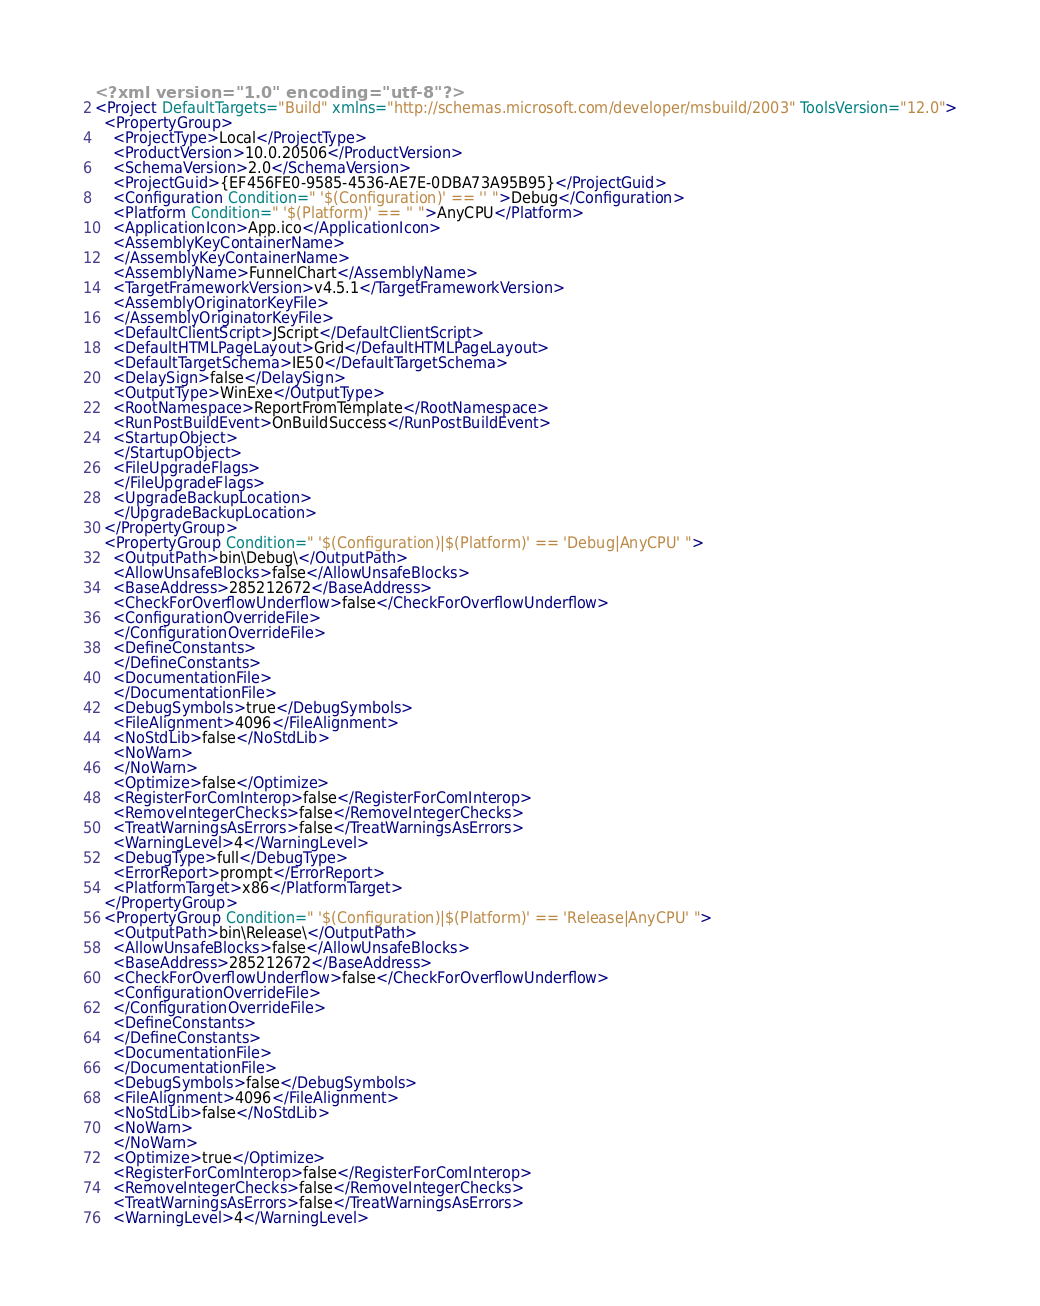Convert code to text. <code><loc_0><loc_0><loc_500><loc_500><_XML_><?xml version="1.0" encoding="utf-8"?>
<Project DefaultTargets="Build" xmlns="http://schemas.microsoft.com/developer/msbuild/2003" ToolsVersion="12.0">
  <PropertyGroup>
    <ProjectType>Local</ProjectType>
    <ProductVersion>10.0.20506</ProductVersion>
    <SchemaVersion>2.0</SchemaVersion>
    <ProjectGuid>{EF456FE0-9585-4536-AE7E-0DBA73A95B95}</ProjectGuid>
    <Configuration Condition=" '$(Configuration)' == '' ">Debug</Configuration>
    <Platform Condition=" '$(Platform)' == '' ">AnyCPU</Platform>
    <ApplicationIcon>App.ico</ApplicationIcon>
    <AssemblyKeyContainerName>
    </AssemblyKeyContainerName>
    <AssemblyName>FunnelChart</AssemblyName>
    <TargetFrameworkVersion>v4.5.1</TargetFrameworkVersion>
    <AssemblyOriginatorKeyFile>
    </AssemblyOriginatorKeyFile>
    <DefaultClientScript>JScript</DefaultClientScript>
    <DefaultHTMLPageLayout>Grid</DefaultHTMLPageLayout>
    <DefaultTargetSchema>IE50</DefaultTargetSchema>
    <DelaySign>false</DelaySign>
    <OutputType>WinExe</OutputType>
    <RootNamespace>ReportFromTemplate</RootNamespace>
    <RunPostBuildEvent>OnBuildSuccess</RunPostBuildEvent>
    <StartupObject>
    </StartupObject>
    <FileUpgradeFlags>
    </FileUpgradeFlags>
    <UpgradeBackupLocation>
    </UpgradeBackupLocation>
  </PropertyGroup>
  <PropertyGroup Condition=" '$(Configuration)|$(Platform)' == 'Debug|AnyCPU' ">
    <OutputPath>bin\Debug\</OutputPath>
    <AllowUnsafeBlocks>false</AllowUnsafeBlocks>
    <BaseAddress>285212672</BaseAddress>
    <CheckForOverflowUnderflow>false</CheckForOverflowUnderflow>
    <ConfigurationOverrideFile>
    </ConfigurationOverrideFile>
    <DefineConstants>
    </DefineConstants>
    <DocumentationFile>
    </DocumentationFile>
    <DebugSymbols>true</DebugSymbols>
    <FileAlignment>4096</FileAlignment>
    <NoStdLib>false</NoStdLib>
    <NoWarn>
    </NoWarn>
    <Optimize>false</Optimize>
    <RegisterForComInterop>false</RegisterForComInterop>
    <RemoveIntegerChecks>false</RemoveIntegerChecks>
    <TreatWarningsAsErrors>false</TreatWarningsAsErrors>
    <WarningLevel>4</WarningLevel>
    <DebugType>full</DebugType>
    <ErrorReport>prompt</ErrorReport>
    <PlatformTarget>x86</PlatformTarget>
  </PropertyGroup>
  <PropertyGroup Condition=" '$(Configuration)|$(Platform)' == 'Release|AnyCPU' ">
    <OutputPath>bin\Release\</OutputPath>
    <AllowUnsafeBlocks>false</AllowUnsafeBlocks>
    <BaseAddress>285212672</BaseAddress>
    <CheckForOverflowUnderflow>false</CheckForOverflowUnderflow>
    <ConfigurationOverrideFile>
    </ConfigurationOverrideFile>
    <DefineConstants>
    </DefineConstants>
    <DocumentationFile>
    </DocumentationFile>
    <DebugSymbols>false</DebugSymbols>
    <FileAlignment>4096</FileAlignment>
    <NoStdLib>false</NoStdLib>
    <NoWarn>
    </NoWarn>
    <Optimize>true</Optimize>
    <RegisterForComInterop>false</RegisterForComInterop>
    <RemoveIntegerChecks>false</RemoveIntegerChecks>
    <TreatWarningsAsErrors>false</TreatWarningsAsErrors>
    <WarningLevel>4</WarningLevel></code> 